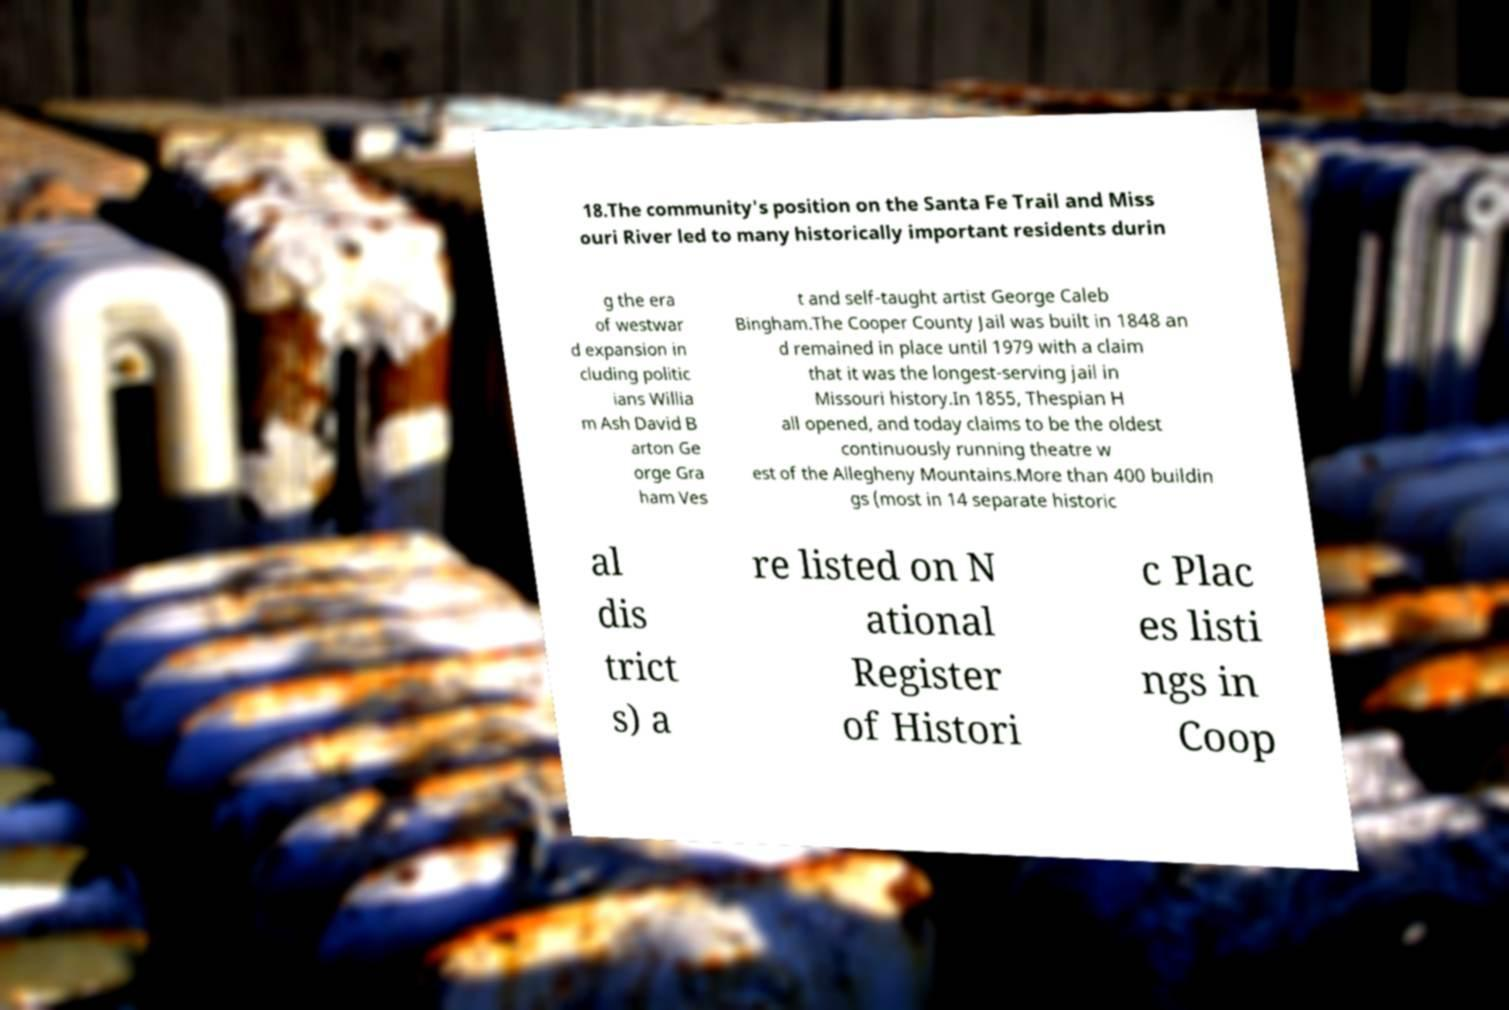Can you accurately transcribe the text from the provided image for me? 18.The community's position on the Santa Fe Trail and Miss ouri River led to many historically important residents durin g the era of westwar d expansion in cluding politic ians Willia m Ash David B arton Ge orge Gra ham Ves t and self-taught artist George Caleb Bingham.The Cooper County Jail was built in 1848 an d remained in place until 1979 with a claim that it was the longest-serving jail in Missouri history.In 1855, Thespian H all opened, and today claims to be the oldest continuously running theatre w est of the Allegheny Mountains.More than 400 buildin gs (most in 14 separate historic al dis trict s) a re listed on N ational Register of Histori c Plac es listi ngs in Coop 